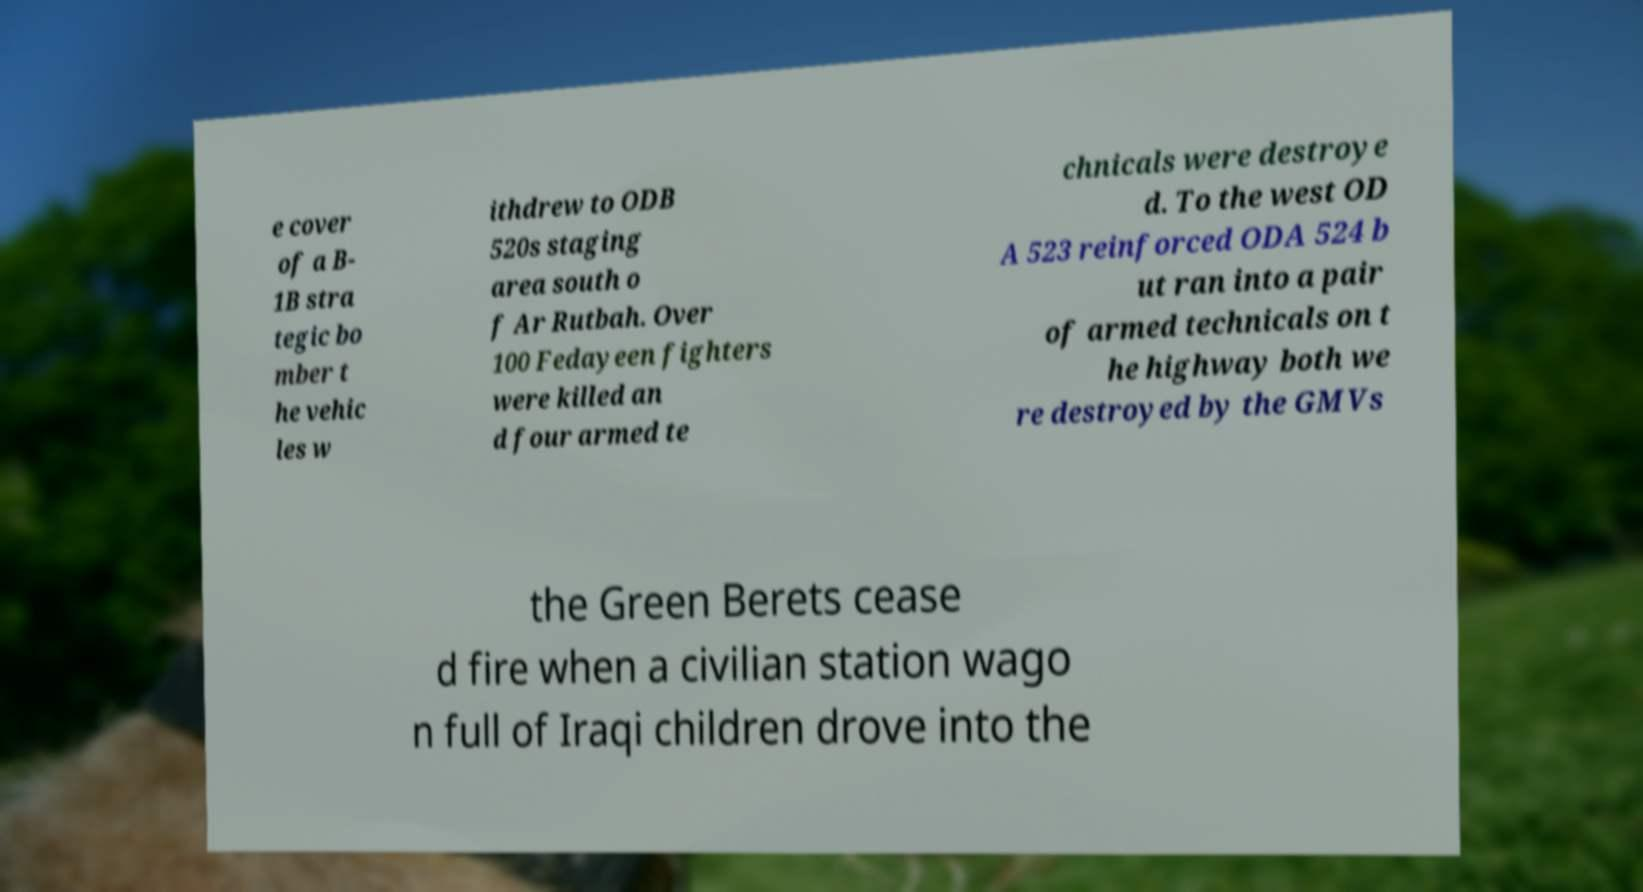What messages or text are displayed in this image? I need them in a readable, typed format. e cover of a B- 1B stra tegic bo mber t he vehic les w ithdrew to ODB 520s staging area south o f Ar Rutbah. Over 100 Fedayeen fighters were killed an d four armed te chnicals were destroye d. To the west OD A 523 reinforced ODA 524 b ut ran into a pair of armed technicals on t he highway both we re destroyed by the GMVs the Green Berets cease d fire when a civilian station wago n full of Iraqi children drove into the 